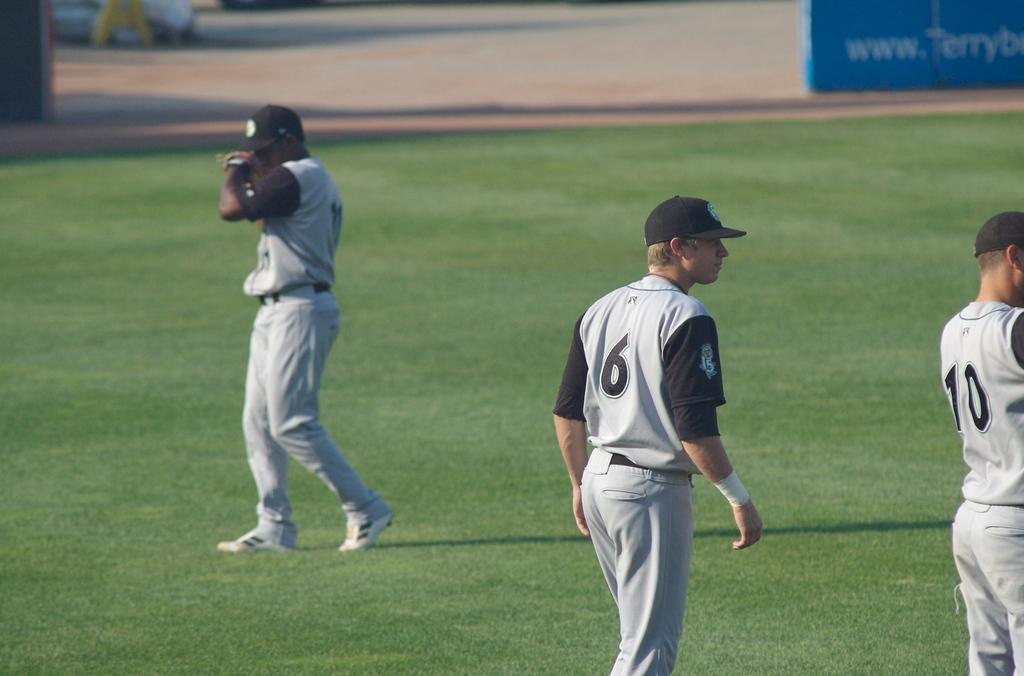What number is the player in the middle?
Offer a very short reply. 6. What is the number of the player on the right?
Provide a succinct answer. 10. 